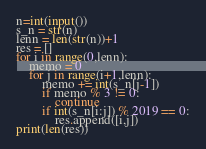<code> <loc_0><loc_0><loc_500><loc_500><_Python_>n=int(input())
s_n = str(n)
lenn = len(str(n))+1
res = []
for i in range(0,lenn):
    memo = 0
    for j in range(i+1,lenn):
        memo += int(s_n[j-1])
        if memo % 3 != 0:
            continue
        if int(s_n[i:j]) % 2019 == 0:
            res.append([i,j])
print(len(res))</code> 